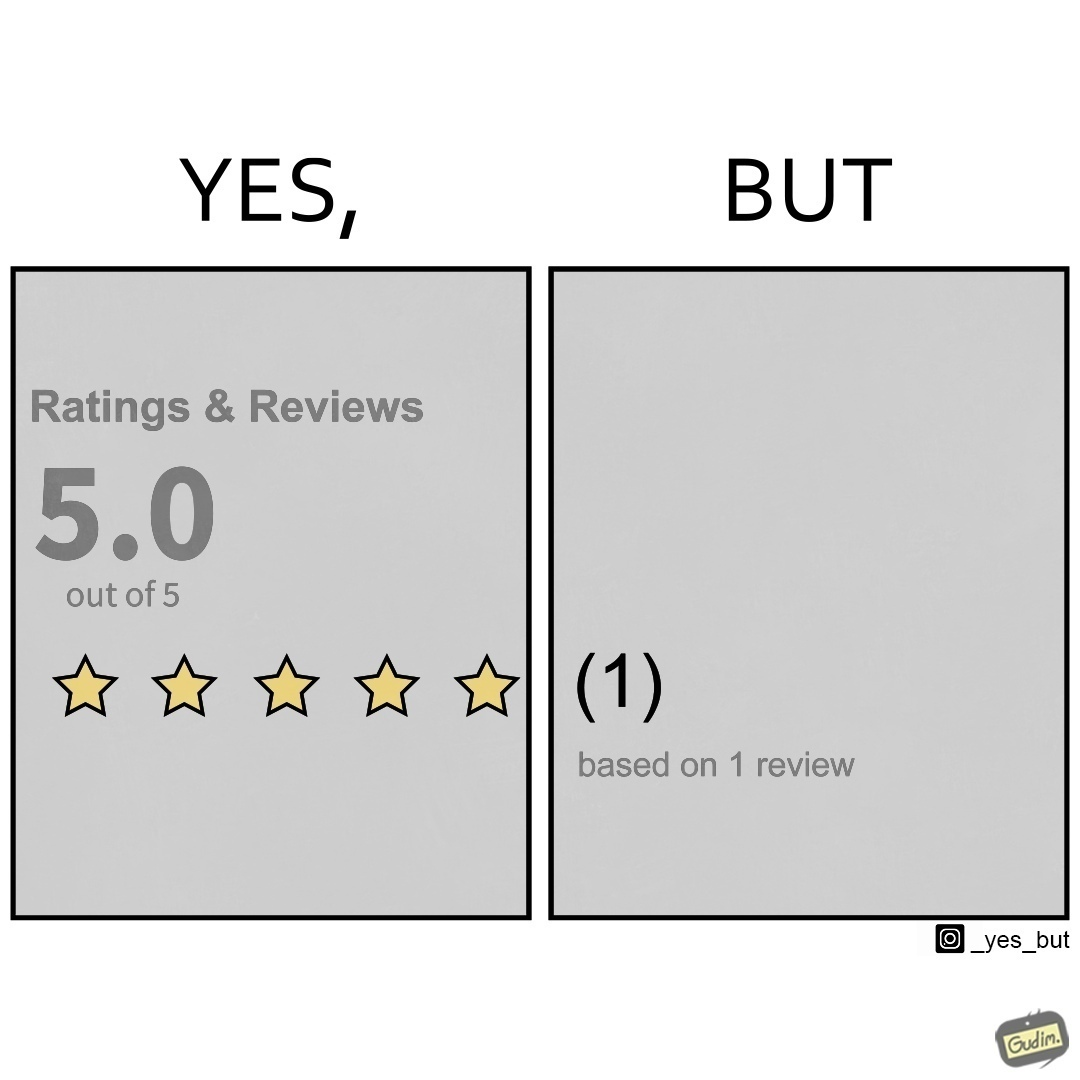Is there satirical content in this image? Yes, this image is satirical. 